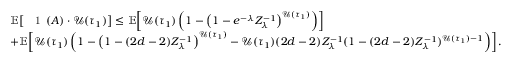<formula> <loc_0><loc_0><loc_500><loc_500>\begin{array} { r l } & { \mathbb { E } \, \left [ { \mathfrak 1 } ( A ) \cdot \mathcal { U } ( \tau _ { 1 } ) \right ] \leq \mathbb { E } \, \left [ \mathcal { U } ( \tau _ { 1 } ) \left ( 1 - \left ( 1 - e ^ { - \lambda } Z _ { \lambda } ^ { - 1 } \right ) ^ { \mathcal { U } ( \tau _ { 1 } ) } \right ) \right ] } \\ & { + \mathbb { E } \, \left [ \mathcal { U } ( \tau _ { 1 } ) \left ( 1 - \left ( 1 - ( 2 d - 2 ) Z _ { \lambda } ^ { - 1 } \right ) ^ { \mathcal { U } ( \tau _ { 1 } ) } - \mathcal { U } ( \tau _ { 1 } ) ( 2 d - 2 ) Z _ { \lambda } ^ { - 1 } ( 1 - ( 2 d - 2 ) Z _ { \lambda } ^ { - 1 } ) ^ { \mathcal { U } ( \tau _ { 1 } ) - 1 } \right ) \right ] . } \end{array}</formula> 